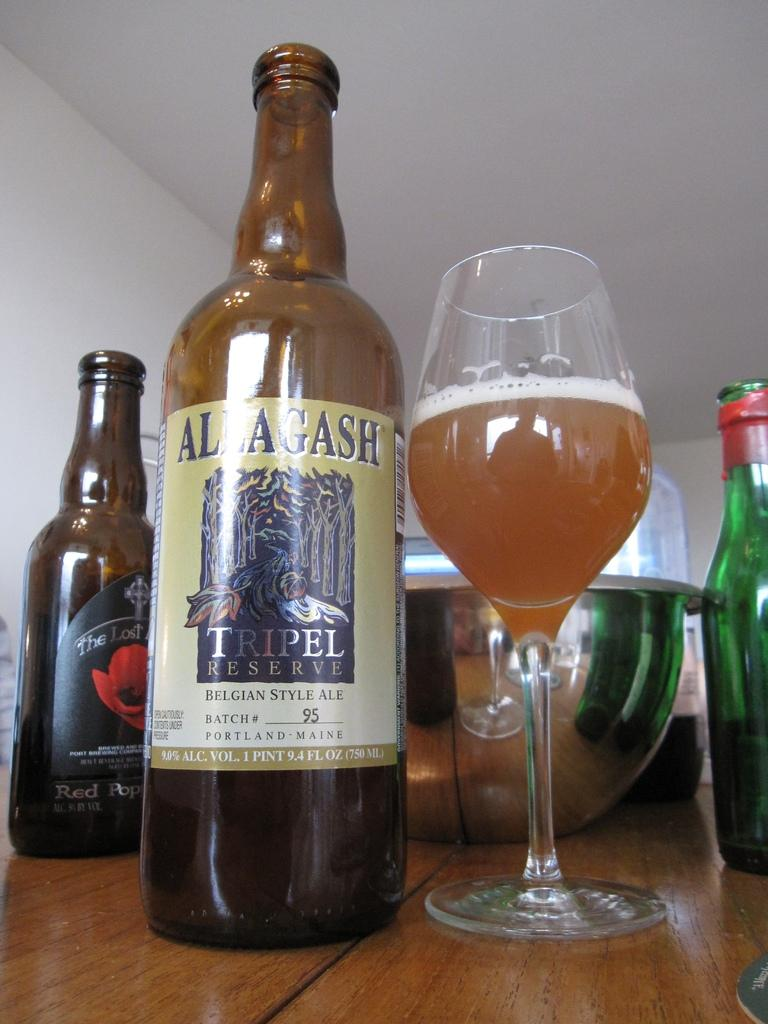<image>
Render a clear and concise summary of the photo. A bottle of Allagash Tripel Reserve Belgian Style Ale next to a glass. 